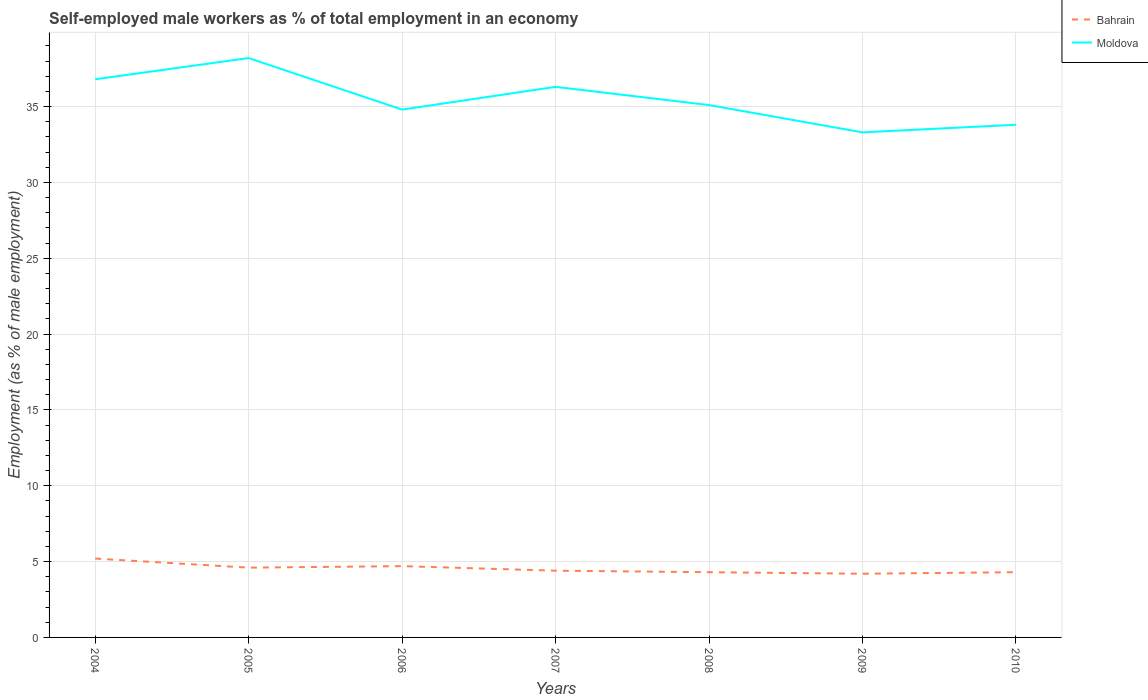Does the line corresponding to Moldova intersect with the line corresponding to Bahrain?
Make the answer very short. No. Is the number of lines equal to the number of legend labels?
Ensure brevity in your answer.  Yes. Across all years, what is the maximum percentage of self-employed male workers in Moldova?
Your response must be concise. 33.3. In which year was the percentage of self-employed male workers in Bahrain maximum?
Make the answer very short. 2009. What is the total percentage of self-employed male workers in Bahrain in the graph?
Give a very brief answer. 0.4. What is the difference between the highest and the second highest percentage of self-employed male workers in Bahrain?
Offer a very short reply. 1. How many lines are there?
Make the answer very short. 2. Does the graph contain grids?
Your answer should be compact. Yes. Where does the legend appear in the graph?
Your response must be concise. Top right. How are the legend labels stacked?
Ensure brevity in your answer.  Vertical. What is the title of the graph?
Your answer should be very brief. Self-employed male workers as % of total employment in an economy. Does "Nepal" appear as one of the legend labels in the graph?
Provide a short and direct response. No. What is the label or title of the Y-axis?
Your answer should be compact. Employment (as % of male employment). What is the Employment (as % of male employment) in Bahrain in 2004?
Your answer should be compact. 5.2. What is the Employment (as % of male employment) in Moldova in 2004?
Your answer should be compact. 36.8. What is the Employment (as % of male employment) in Bahrain in 2005?
Keep it short and to the point. 4.6. What is the Employment (as % of male employment) in Moldova in 2005?
Your answer should be compact. 38.2. What is the Employment (as % of male employment) of Bahrain in 2006?
Give a very brief answer. 4.7. What is the Employment (as % of male employment) of Moldova in 2006?
Provide a succinct answer. 34.8. What is the Employment (as % of male employment) in Bahrain in 2007?
Your response must be concise. 4.4. What is the Employment (as % of male employment) of Moldova in 2007?
Offer a terse response. 36.3. What is the Employment (as % of male employment) of Bahrain in 2008?
Provide a succinct answer. 4.3. What is the Employment (as % of male employment) of Moldova in 2008?
Your answer should be very brief. 35.1. What is the Employment (as % of male employment) in Bahrain in 2009?
Provide a short and direct response. 4.2. What is the Employment (as % of male employment) of Moldova in 2009?
Give a very brief answer. 33.3. What is the Employment (as % of male employment) in Bahrain in 2010?
Ensure brevity in your answer.  4.3. What is the Employment (as % of male employment) of Moldova in 2010?
Your answer should be very brief. 33.8. Across all years, what is the maximum Employment (as % of male employment) in Bahrain?
Make the answer very short. 5.2. Across all years, what is the maximum Employment (as % of male employment) of Moldova?
Offer a terse response. 38.2. Across all years, what is the minimum Employment (as % of male employment) of Bahrain?
Offer a very short reply. 4.2. Across all years, what is the minimum Employment (as % of male employment) of Moldova?
Offer a very short reply. 33.3. What is the total Employment (as % of male employment) in Bahrain in the graph?
Provide a succinct answer. 31.7. What is the total Employment (as % of male employment) of Moldova in the graph?
Provide a succinct answer. 248.3. What is the difference between the Employment (as % of male employment) in Moldova in 2004 and that in 2008?
Your answer should be very brief. 1.7. What is the difference between the Employment (as % of male employment) of Bahrain in 2004 and that in 2010?
Make the answer very short. 0.9. What is the difference between the Employment (as % of male employment) of Bahrain in 2005 and that in 2006?
Make the answer very short. -0.1. What is the difference between the Employment (as % of male employment) in Moldova in 2005 and that in 2006?
Your answer should be very brief. 3.4. What is the difference between the Employment (as % of male employment) of Bahrain in 2005 and that in 2007?
Provide a short and direct response. 0.2. What is the difference between the Employment (as % of male employment) in Bahrain in 2005 and that in 2009?
Ensure brevity in your answer.  0.4. What is the difference between the Employment (as % of male employment) of Moldova in 2005 and that in 2009?
Your answer should be compact. 4.9. What is the difference between the Employment (as % of male employment) in Moldova in 2005 and that in 2010?
Offer a very short reply. 4.4. What is the difference between the Employment (as % of male employment) of Bahrain in 2006 and that in 2007?
Your answer should be compact. 0.3. What is the difference between the Employment (as % of male employment) of Bahrain in 2006 and that in 2008?
Offer a very short reply. 0.4. What is the difference between the Employment (as % of male employment) of Moldova in 2007 and that in 2010?
Ensure brevity in your answer.  2.5. What is the difference between the Employment (as % of male employment) of Moldova in 2008 and that in 2009?
Your answer should be compact. 1.8. What is the difference between the Employment (as % of male employment) in Moldova in 2008 and that in 2010?
Provide a short and direct response. 1.3. What is the difference between the Employment (as % of male employment) in Bahrain in 2009 and that in 2010?
Your response must be concise. -0.1. What is the difference between the Employment (as % of male employment) in Bahrain in 2004 and the Employment (as % of male employment) in Moldova in 2005?
Provide a succinct answer. -33. What is the difference between the Employment (as % of male employment) in Bahrain in 2004 and the Employment (as % of male employment) in Moldova in 2006?
Your response must be concise. -29.6. What is the difference between the Employment (as % of male employment) in Bahrain in 2004 and the Employment (as % of male employment) in Moldova in 2007?
Offer a terse response. -31.1. What is the difference between the Employment (as % of male employment) in Bahrain in 2004 and the Employment (as % of male employment) in Moldova in 2008?
Make the answer very short. -29.9. What is the difference between the Employment (as % of male employment) of Bahrain in 2004 and the Employment (as % of male employment) of Moldova in 2009?
Make the answer very short. -28.1. What is the difference between the Employment (as % of male employment) of Bahrain in 2004 and the Employment (as % of male employment) of Moldova in 2010?
Keep it short and to the point. -28.6. What is the difference between the Employment (as % of male employment) of Bahrain in 2005 and the Employment (as % of male employment) of Moldova in 2006?
Your answer should be compact. -30.2. What is the difference between the Employment (as % of male employment) of Bahrain in 2005 and the Employment (as % of male employment) of Moldova in 2007?
Ensure brevity in your answer.  -31.7. What is the difference between the Employment (as % of male employment) of Bahrain in 2005 and the Employment (as % of male employment) of Moldova in 2008?
Your answer should be compact. -30.5. What is the difference between the Employment (as % of male employment) of Bahrain in 2005 and the Employment (as % of male employment) of Moldova in 2009?
Offer a very short reply. -28.7. What is the difference between the Employment (as % of male employment) in Bahrain in 2005 and the Employment (as % of male employment) in Moldova in 2010?
Your answer should be compact. -29.2. What is the difference between the Employment (as % of male employment) of Bahrain in 2006 and the Employment (as % of male employment) of Moldova in 2007?
Offer a terse response. -31.6. What is the difference between the Employment (as % of male employment) in Bahrain in 2006 and the Employment (as % of male employment) in Moldova in 2008?
Provide a succinct answer. -30.4. What is the difference between the Employment (as % of male employment) of Bahrain in 2006 and the Employment (as % of male employment) of Moldova in 2009?
Give a very brief answer. -28.6. What is the difference between the Employment (as % of male employment) of Bahrain in 2006 and the Employment (as % of male employment) of Moldova in 2010?
Your answer should be very brief. -29.1. What is the difference between the Employment (as % of male employment) of Bahrain in 2007 and the Employment (as % of male employment) of Moldova in 2008?
Keep it short and to the point. -30.7. What is the difference between the Employment (as % of male employment) in Bahrain in 2007 and the Employment (as % of male employment) in Moldova in 2009?
Ensure brevity in your answer.  -28.9. What is the difference between the Employment (as % of male employment) in Bahrain in 2007 and the Employment (as % of male employment) in Moldova in 2010?
Your answer should be very brief. -29.4. What is the difference between the Employment (as % of male employment) in Bahrain in 2008 and the Employment (as % of male employment) in Moldova in 2010?
Your response must be concise. -29.5. What is the difference between the Employment (as % of male employment) in Bahrain in 2009 and the Employment (as % of male employment) in Moldova in 2010?
Offer a terse response. -29.6. What is the average Employment (as % of male employment) of Bahrain per year?
Ensure brevity in your answer.  4.53. What is the average Employment (as % of male employment) of Moldova per year?
Your answer should be compact. 35.47. In the year 2004, what is the difference between the Employment (as % of male employment) in Bahrain and Employment (as % of male employment) in Moldova?
Your response must be concise. -31.6. In the year 2005, what is the difference between the Employment (as % of male employment) in Bahrain and Employment (as % of male employment) in Moldova?
Ensure brevity in your answer.  -33.6. In the year 2006, what is the difference between the Employment (as % of male employment) in Bahrain and Employment (as % of male employment) in Moldova?
Your answer should be very brief. -30.1. In the year 2007, what is the difference between the Employment (as % of male employment) of Bahrain and Employment (as % of male employment) of Moldova?
Keep it short and to the point. -31.9. In the year 2008, what is the difference between the Employment (as % of male employment) of Bahrain and Employment (as % of male employment) of Moldova?
Offer a terse response. -30.8. In the year 2009, what is the difference between the Employment (as % of male employment) of Bahrain and Employment (as % of male employment) of Moldova?
Your response must be concise. -29.1. In the year 2010, what is the difference between the Employment (as % of male employment) in Bahrain and Employment (as % of male employment) in Moldova?
Ensure brevity in your answer.  -29.5. What is the ratio of the Employment (as % of male employment) of Bahrain in 2004 to that in 2005?
Your answer should be compact. 1.13. What is the ratio of the Employment (as % of male employment) in Moldova in 2004 to that in 2005?
Your response must be concise. 0.96. What is the ratio of the Employment (as % of male employment) in Bahrain in 2004 to that in 2006?
Your answer should be compact. 1.11. What is the ratio of the Employment (as % of male employment) of Moldova in 2004 to that in 2006?
Provide a succinct answer. 1.06. What is the ratio of the Employment (as % of male employment) in Bahrain in 2004 to that in 2007?
Offer a terse response. 1.18. What is the ratio of the Employment (as % of male employment) of Moldova in 2004 to that in 2007?
Your answer should be very brief. 1.01. What is the ratio of the Employment (as % of male employment) of Bahrain in 2004 to that in 2008?
Keep it short and to the point. 1.21. What is the ratio of the Employment (as % of male employment) in Moldova in 2004 to that in 2008?
Your response must be concise. 1.05. What is the ratio of the Employment (as % of male employment) in Bahrain in 2004 to that in 2009?
Your answer should be very brief. 1.24. What is the ratio of the Employment (as % of male employment) of Moldova in 2004 to that in 2009?
Ensure brevity in your answer.  1.11. What is the ratio of the Employment (as % of male employment) of Bahrain in 2004 to that in 2010?
Your answer should be very brief. 1.21. What is the ratio of the Employment (as % of male employment) of Moldova in 2004 to that in 2010?
Ensure brevity in your answer.  1.09. What is the ratio of the Employment (as % of male employment) in Bahrain in 2005 to that in 2006?
Your answer should be very brief. 0.98. What is the ratio of the Employment (as % of male employment) in Moldova in 2005 to that in 2006?
Give a very brief answer. 1.1. What is the ratio of the Employment (as % of male employment) in Bahrain in 2005 to that in 2007?
Provide a short and direct response. 1.05. What is the ratio of the Employment (as % of male employment) of Moldova in 2005 to that in 2007?
Provide a succinct answer. 1.05. What is the ratio of the Employment (as % of male employment) of Bahrain in 2005 to that in 2008?
Your answer should be compact. 1.07. What is the ratio of the Employment (as % of male employment) in Moldova in 2005 to that in 2008?
Your answer should be compact. 1.09. What is the ratio of the Employment (as % of male employment) in Bahrain in 2005 to that in 2009?
Offer a terse response. 1.1. What is the ratio of the Employment (as % of male employment) of Moldova in 2005 to that in 2009?
Offer a terse response. 1.15. What is the ratio of the Employment (as % of male employment) of Bahrain in 2005 to that in 2010?
Give a very brief answer. 1.07. What is the ratio of the Employment (as % of male employment) in Moldova in 2005 to that in 2010?
Your answer should be compact. 1.13. What is the ratio of the Employment (as % of male employment) of Bahrain in 2006 to that in 2007?
Keep it short and to the point. 1.07. What is the ratio of the Employment (as % of male employment) of Moldova in 2006 to that in 2007?
Provide a succinct answer. 0.96. What is the ratio of the Employment (as % of male employment) in Bahrain in 2006 to that in 2008?
Ensure brevity in your answer.  1.09. What is the ratio of the Employment (as % of male employment) of Moldova in 2006 to that in 2008?
Ensure brevity in your answer.  0.99. What is the ratio of the Employment (as % of male employment) in Bahrain in 2006 to that in 2009?
Keep it short and to the point. 1.12. What is the ratio of the Employment (as % of male employment) in Moldova in 2006 to that in 2009?
Provide a succinct answer. 1.04. What is the ratio of the Employment (as % of male employment) in Bahrain in 2006 to that in 2010?
Your answer should be compact. 1.09. What is the ratio of the Employment (as % of male employment) of Moldova in 2006 to that in 2010?
Your answer should be very brief. 1.03. What is the ratio of the Employment (as % of male employment) of Bahrain in 2007 to that in 2008?
Your response must be concise. 1.02. What is the ratio of the Employment (as % of male employment) of Moldova in 2007 to that in 2008?
Provide a short and direct response. 1.03. What is the ratio of the Employment (as % of male employment) of Bahrain in 2007 to that in 2009?
Make the answer very short. 1.05. What is the ratio of the Employment (as % of male employment) in Moldova in 2007 to that in 2009?
Make the answer very short. 1.09. What is the ratio of the Employment (as % of male employment) in Bahrain in 2007 to that in 2010?
Ensure brevity in your answer.  1.02. What is the ratio of the Employment (as % of male employment) of Moldova in 2007 to that in 2010?
Keep it short and to the point. 1.07. What is the ratio of the Employment (as % of male employment) of Bahrain in 2008 to that in 2009?
Provide a succinct answer. 1.02. What is the ratio of the Employment (as % of male employment) in Moldova in 2008 to that in 2009?
Provide a succinct answer. 1.05. What is the ratio of the Employment (as % of male employment) in Bahrain in 2008 to that in 2010?
Give a very brief answer. 1. What is the ratio of the Employment (as % of male employment) in Moldova in 2008 to that in 2010?
Offer a very short reply. 1.04. What is the ratio of the Employment (as % of male employment) of Bahrain in 2009 to that in 2010?
Make the answer very short. 0.98. What is the ratio of the Employment (as % of male employment) in Moldova in 2009 to that in 2010?
Provide a short and direct response. 0.99. What is the difference between the highest and the second highest Employment (as % of male employment) of Moldova?
Your answer should be very brief. 1.4. What is the difference between the highest and the lowest Employment (as % of male employment) of Moldova?
Ensure brevity in your answer.  4.9. 